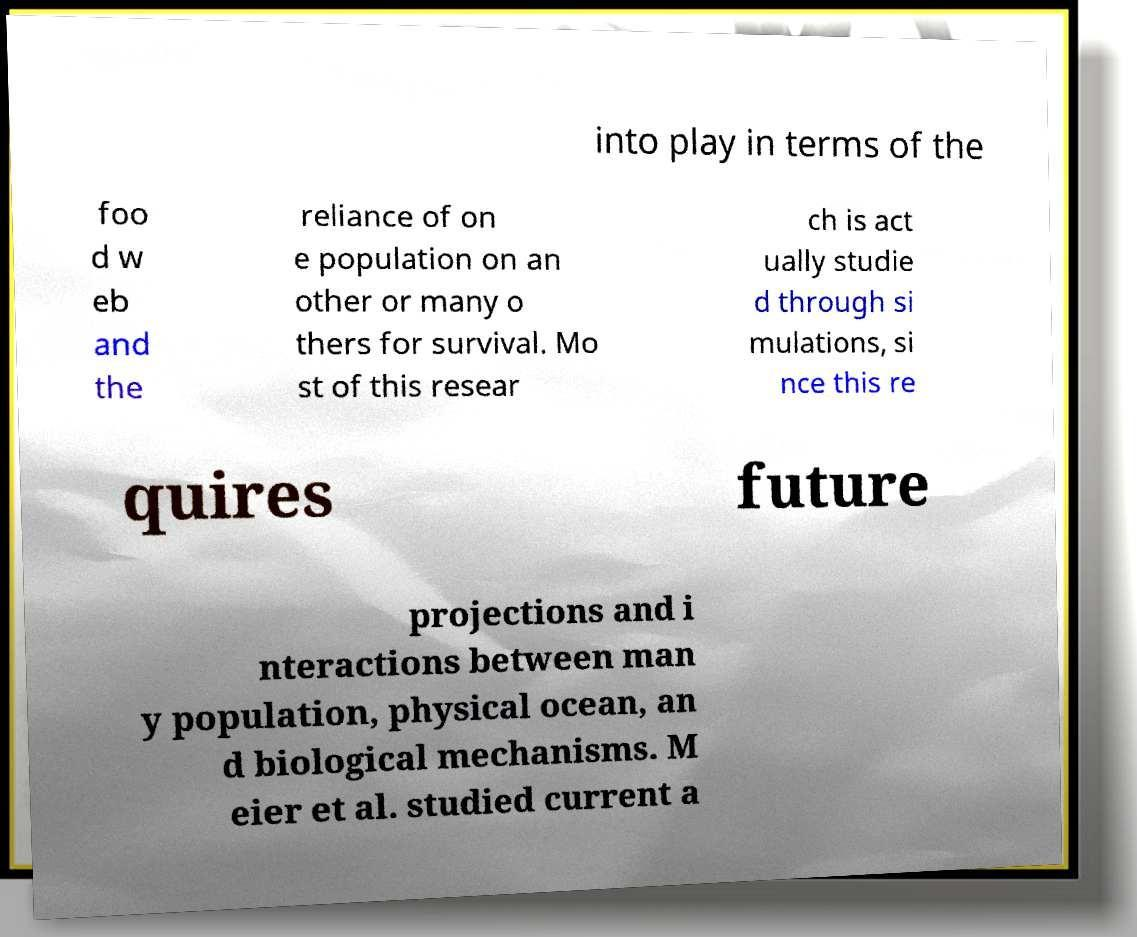Can you accurately transcribe the text from the provided image for me? into play in terms of the foo d w eb and the reliance of on e population on an other or many o thers for survival. Mo st of this resear ch is act ually studie d through si mulations, si nce this re quires future projections and i nteractions between man y population, physical ocean, an d biological mechanisms. M eier et al. studied current a 